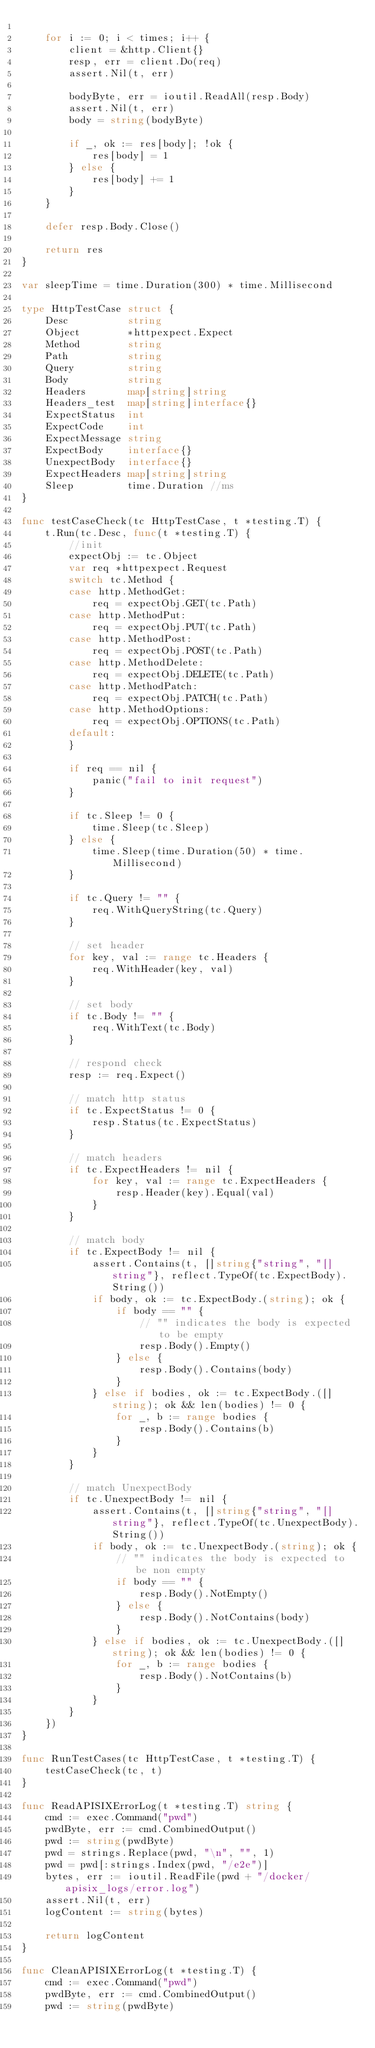Convert code to text. <code><loc_0><loc_0><loc_500><loc_500><_Go_>
	for i := 0; i < times; i++ {
		client = &http.Client{}
		resp, err = client.Do(req)
		assert.Nil(t, err)

		bodyByte, err = ioutil.ReadAll(resp.Body)
		assert.Nil(t, err)
		body = string(bodyByte)

		if _, ok := res[body]; !ok {
			res[body] = 1
		} else {
			res[body] += 1
		}
	}

	defer resp.Body.Close()

	return res
}

var sleepTime = time.Duration(300) * time.Millisecond

type HttpTestCase struct {
	Desc          string
	Object        *httpexpect.Expect
	Method        string
	Path          string
	Query         string
	Body          string
	Headers       map[string]string
	Headers_test  map[string]interface{}
	ExpectStatus  int
	ExpectCode    int
	ExpectMessage string
	ExpectBody    interface{}
	UnexpectBody  interface{}
	ExpectHeaders map[string]string
	Sleep         time.Duration //ms
}

func testCaseCheck(tc HttpTestCase, t *testing.T) {
	t.Run(tc.Desc, func(t *testing.T) {
		//init
		expectObj := tc.Object
		var req *httpexpect.Request
		switch tc.Method {
		case http.MethodGet:
			req = expectObj.GET(tc.Path)
		case http.MethodPut:
			req = expectObj.PUT(tc.Path)
		case http.MethodPost:
			req = expectObj.POST(tc.Path)
		case http.MethodDelete:
			req = expectObj.DELETE(tc.Path)
		case http.MethodPatch:
			req = expectObj.PATCH(tc.Path)
		case http.MethodOptions:
			req = expectObj.OPTIONS(tc.Path)
		default:
		}

		if req == nil {
			panic("fail to init request")
		}

		if tc.Sleep != 0 {
			time.Sleep(tc.Sleep)
		} else {
			time.Sleep(time.Duration(50) * time.Millisecond)
		}

		if tc.Query != "" {
			req.WithQueryString(tc.Query)
		}

		// set header
		for key, val := range tc.Headers {
			req.WithHeader(key, val)
		}

		// set body
		if tc.Body != "" {
			req.WithText(tc.Body)
		}

		// respond check
		resp := req.Expect()

		// match http status
		if tc.ExpectStatus != 0 {
			resp.Status(tc.ExpectStatus)
		}

		// match headers
		if tc.ExpectHeaders != nil {
			for key, val := range tc.ExpectHeaders {
				resp.Header(key).Equal(val)
			}
		}

		// match body
		if tc.ExpectBody != nil {
			assert.Contains(t, []string{"string", "[]string"}, reflect.TypeOf(tc.ExpectBody).String())
			if body, ok := tc.ExpectBody.(string); ok {
				if body == "" {
					// "" indicates the body is expected to be empty
					resp.Body().Empty()
				} else {
					resp.Body().Contains(body)
				}
			} else if bodies, ok := tc.ExpectBody.([]string); ok && len(bodies) != 0 {
				for _, b := range bodies {
					resp.Body().Contains(b)
				}
			}
		}

		// match UnexpectBody
		if tc.UnexpectBody != nil {
			assert.Contains(t, []string{"string", "[]string"}, reflect.TypeOf(tc.UnexpectBody).String())
			if body, ok := tc.UnexpectBody.(string); ok {
				// "" indicates the body is expected to be non empty
				if body == "" {
					resp.Body().NotEmpty()
				} else {
					resp.Body().NotContains(body)
				}
			} else if bodies, ok := tc.UnexpectBody.([]string); ok && len(bodies) != 0 {
				for _, b := range bodies {
					resp.Body().NotContains(b)
				}
			}
		}
	})
}

func RunTestCases(tc HttpTestCase, t *testing.T) {
	testCaseCheck(tc, t)
}

func ReadAPISIXErrorLog(t *testing.T) string {
	cmd := exec.Command("pwd")
	pwdByte, err := cmd.CombinedOutput()
	pwd := string(pwdByte)
	pwd = strings.Replace(pwd, "\n", "", 1)
	pwd = pwd[:strings.Index(pwd, "/e2e")]
	bytes, err := ioutil.ReadFile(pwd + "/docker/apisix_logs/error.log")
	assert.Nil(t, err)
	logContent := string(bytes)

	return logContent
}

func CleanAPISIXErrorLog(t *testing.T) {
	cmd := exec.Command("pwd")
	pwdByte, err := cmd.CombinedOutput()
	pwd := string(pwdByte)</code> 